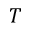Convert formula to latex. <formula><loc_0><loc_0><loc_500><loc_500>T</formula> 